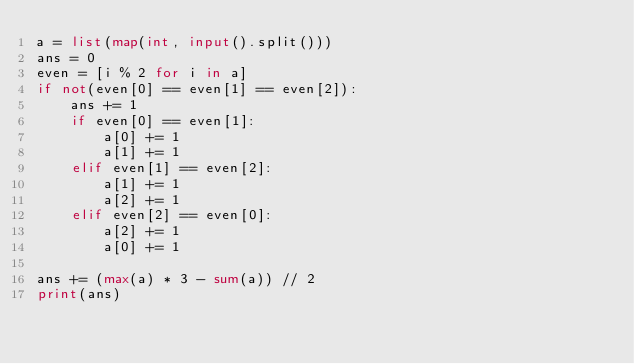<code> <loc_0><loc_0><loc_500><loc_500><_Python_>a = list(map(int, input().split()))
ans = 0
even = [i % 2 for i in a]
if not(even[0] == even[1] == even[2]):
    ans += 1
    if even[0] == even[1]:
        a[0] += 1
        a[1] += 1
    elif even[1] == even[2]:
        a[1] += 1
        a[2] += 1
    elif even[2] == even[0]:
        a[2] += 1
        a[0] += 1

ans += (max(a) * 3 - sum(a)) // 2
print(ans)


</code> 